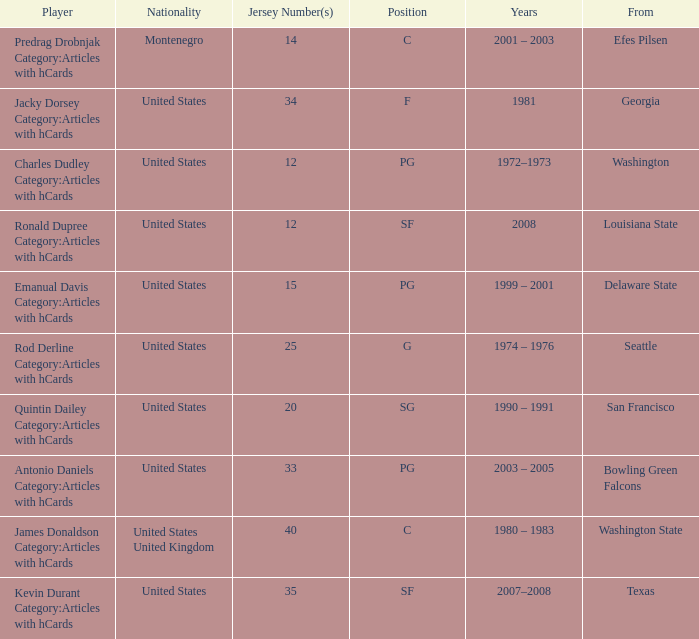What is the smallest jersey number for a player originating from louisiana state? 12.0. 